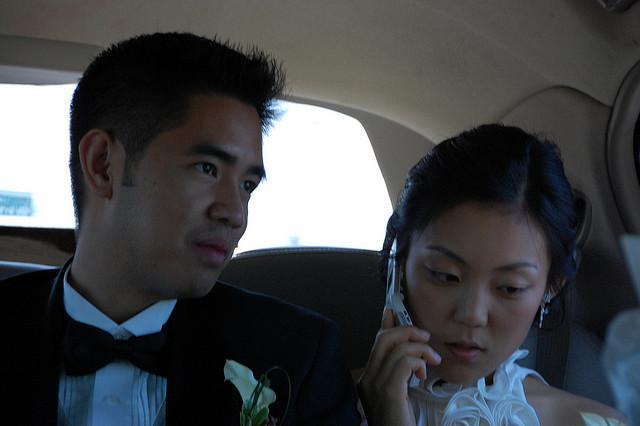How many ties are in the photo?
Give a very brief answer. 1. How many people are there?
Give a very brief answer. 2. How many drinks cups have straw?
Give a very brief answer. 0. 